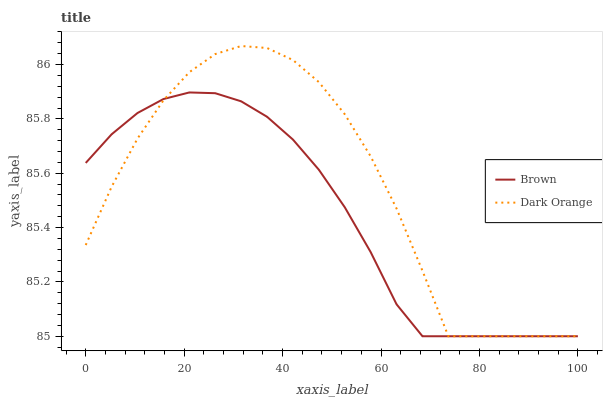Does Brown have the minimum area under the curve?
Answer yes or no. Yes. Does Dark Orange have the maximum area under the curve?
Answer yes or no. Yes. Does Dark Orange have the minimum area under the curve?
Answer yes or no. No. Is Brown the smoothest?
Answer yes or no. Yes. Is Dark Orange the roughest?
Answer yes or no. Yes. Is Dark Orange the smoothest?
Answer yes or no. No. Does Brown have the lowest value?
Answer yes or no. Yes. Does Dark Orange have the highest value?
Answer yes or no. Yes. Does Dark Orange intersect Brown?
Answer yes or no. Yes. Is Dark Orange less than Brown?
Answer yes or no. No. Is Dark Orange greater than Brown?
Answer yes or no. No. 